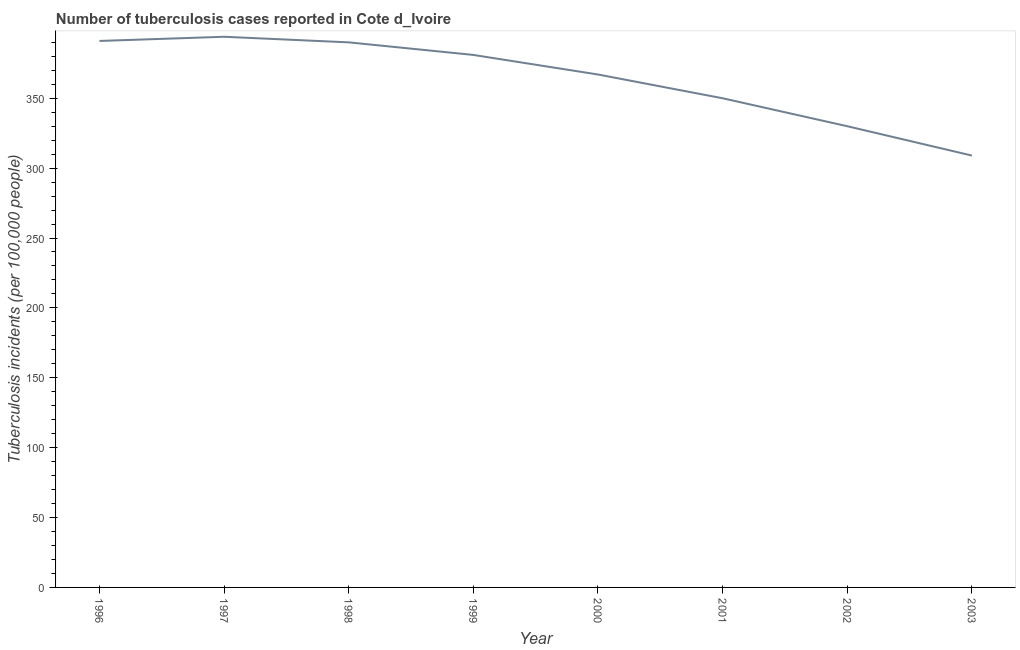What is the number of tuberculosis incidents in 2003?
Give a very brief answer. 309. Across all years, what is the maximum number of tuberculosis incidents?
Provide a short and direct response. 394. Across all years, what is the minimum number of tuberculosis incidents?
Give a very brief answer. 309. What is the sum of the number of tuberculosis incidents?
Give a very brief answer. 2912. What is the difference between the number of tuberculosis incidents in 1998 and 1999?
Your answer should be compact. 9. What is the average number of tuberculosis incidents per year?
Keep it short and to the point. 364. What is the median number of tuberculosis incidents?
Ensure brevity in your answer.  374. In how many years, is the number of tuberculosis incidents greater than 140 ?
Your answer should be very brief. 8. What is the ratio of the number of tuberculosis incidents in 1997 to that in 1998?
Your answer should be very brief. 1.01. Is the sum of the number of tuberculosis incidents in 1998 and 2003 greater than the maximum number of tuberculosis incidents across all years?
Your answer should be compact. Yes. What is the difference between the highest and the lowest number of tuberculosis incidents?
Make the answer very short. 85. Does the number of tuberculosis incidents monotonically increase over the years?
Provide a short and direct response. No. Are the values on the major ticks of Y-axis written in scientific E-notation?
Offer a very short reply. No. What is the title of the graph?
Your answer should be very brief. Number of tuberculosis cases reported in Cote d_Ivoire. What is the label or title of the Y-axis?
Offer a terse response. Tuberculosis incidents (per 100,0 people). What is the Tuberculosis incidents (per 100,000 people) in 1996?
Offer a very short reply. 391. What is the Tuberculosis incidents (per 100,000 people) in 1997?
Your answer should be compact. 394. What is the Tuberculosis incidents (per 100,000 people) of 1998?
Give a very brief answer. 390. What is the Tuberculosis incidents (per 100,000 people) of 1999?
Make the answer very short. 381. What is the Tuberculosis incidents (per 100,000 people) in 2000?
Ensure brevity in your answer.  367. What is the Tuberculosis incidents (per 100,000 people) of 2001?
Offer a very short reply. 350. What is the Tuberculosis incidents (per 100,000 people) of 2002?
Provide a succinct answer. 330. What is the Tuberculosis incidents (per 100,000 people) of 2003?
Ensure brevity in your answer.  309. What is the difference between the Tuberculosis incidents (per 100,000 people) in 1996 and 1997?
Your answer should be compact. -3. What is the difference between the Tuberculosis incidents (per 100,000 people) in 1996 and 1998?
Provide a short and direct response. 1. What is the difference between the Tuberculosis incidents (per 100,000 people) in 1997 and 2000?
Provide a succinct answer. 27. What is the difference between the Tuberculosis incidents (per 100,000 people) in 1997 and 2002?
Give a very brief answer. 64. What is the difference between the Tuberculosis incidents (per 100,000 people) in 1998 and 2000?
Offer a terse response. 23. What is the difference between the Tuberculosis incidents (per 100,000 people) in 1998 and 2003?
Keep it short and to the point. 81. What is the difference between the Tuberculosis incidents (per 100,000 people) in 1999 and 2001?
Your answer should be very brief. 31. What is the difference between the Tuberculosis incidents (per 100,000 people) in 2000 and 2002?
Offer a very short reply. 37. What is the ratio of the Tuberculosis incidents (per 100,000 people) in 1996 to that in 1999?
Your answer should be very brief. 1.03. What is the ratio of the Tuberculosis incidents (per 100,000 people) in 1996 to that in 2000?
Your answer should be very brief. 1.06. What is the ratio of the Tuberculosis incidents (per 100,000 people) in 1996 to that in 2001?
Make the answer very short. 1.12. What is the ratio of the Tuberculosis incidents (per 100,000 people) in 1996 to that in 2002?
Ensure brevity in your answer.  1.19. What is the ratio of the Tuberculosis incidents (per 100,000 people) in 1996 to that in 2003?
Make the answer very short. 1.26. What is the ratio of the Tuberculosis incidents (per 100,000 people) in 1997 to that in 1999?
Make the answer very short. 1.03. What is the ratio of the Tuberculosis incidents (per 100,000 people) in 1997 to that in 2000?
Give a very brief answer. 1.07. What is the ratio of the Tuberculosis incidents (per 100,000 people) in 1997 to that in 2001?
Offer a terse response. 1.13. What is the ratio of the Tuberculosis incidents (per 100,000 people) in 1997 to that in 2002?
Give a very brief answer. 1.19. What is the ratio of the Tuberculosis incidents (per 100,000 people) in 1997 to that in 2003?
Ensure brevity in your answer.  1.27. What is the ratio of the Tuberculosis incidents (per 100,000 people) in 1998 to that in 2000?
Provide a succinct answer. 1.06. What is the ratio of the Tuberculosis incidents (per 100,000 people) in 1998 to that in 2001?
Provide a succinct answer. 1.11. What is the ratio of the Tuberculosis incidents (per 100,000 people) in 1998 to that in 2002?
Ensure brevity in your answer.  1.18. What is the ratio of the Tuberculosis incidents (per 100,000 people) in 1998 to that in 2003?
Offer a very short reply. 1.26. What is the ratio of the Tuberculosis incidents (per 100,000 people) in 1999 to that in 2000?
Ensure brevity in your answer.  1.04. What is the ratio of the Tuberculosis incidents (per 100,000 people) in 1999 to that in 2001?
Offer a very short reply. 1.09. What is the ratio of the Tuberculosis incidents (per 100,000 people) in 1999 to that in 2002?
Keep it short and to the point. 1.16. What is the ratio of the Tuberculosis incidents (per 100,000 people) in 1999 to that in 2003?
Give a very brief answer. 1.23. What is the ratio of the Tuberculosis incidents (per 100,000 people) in 2000 to that in 2001?
Provide a succinct answer. 1.05. What is the ratio of the Tuberculosis incidents (per 100,000 people) in 2000 to that in 2002?
Offer a terse response. 1.11. What is the ratio of the Tuberculosis incidents (per 100,000 people) in 2000 to that in 2003?
Offer a very short reply. 1.19. What is the ratio of the Tuberculosis incidents (per 100,000 people) in 2001 to that in 2002?
Offer a very short reply. 1.06. What is the ratio of the Tuberculosis incidents (per 100,000 people) in 2001 to that in 2003?
Keep it short and to the point. 1.13. What is the ratio of the Tuberculosis incidents (per 100,000 people) in 2002 to that in 2003?
Provide a short and direct response. 1.07. 